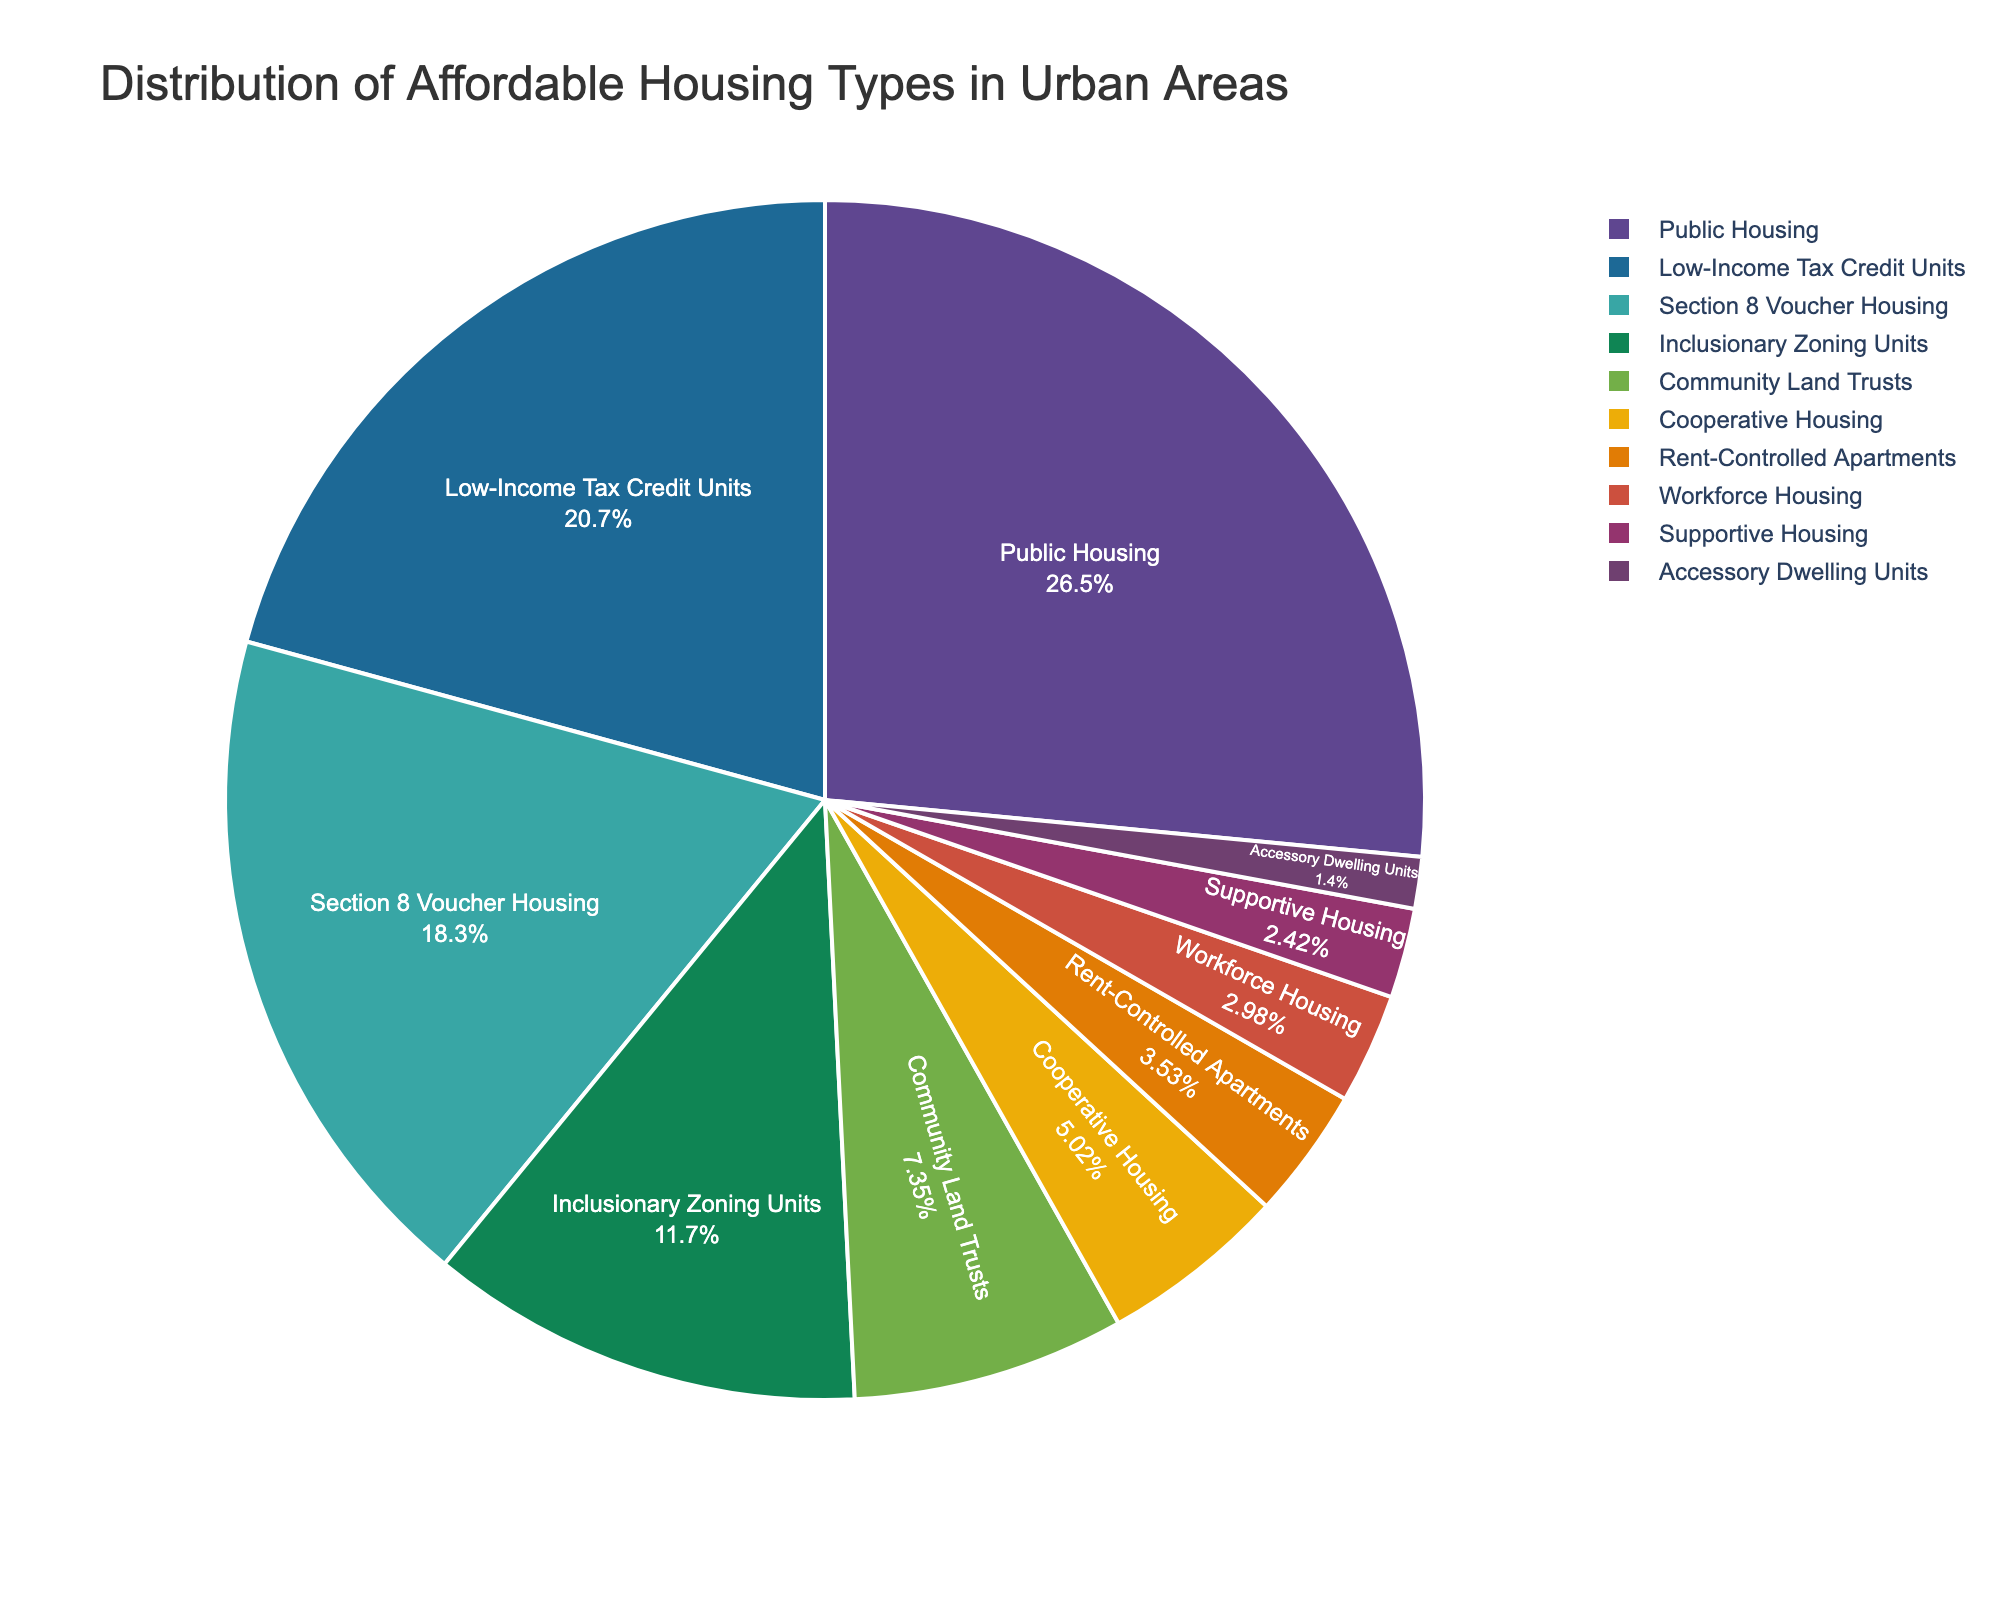What is the largest category in the pie chart? The "Public Housing" category has the largest slice in the pie chart, representing 28.5% of the total distribution.
Answer: Public Housing What is the difference in percentage between the categories "Section 8 Voucher Housing" and "Inclusionary Zoning Units"? "Section 8 Voucher Housing" represents 19.7% and "Inclusionary Zoning Units" represents 12.6%. Subtracting these percentages: 19.7% - 12.6% = 7.1%.
Answer: 7.1% Which affordable housing type constitutes the smallest percentage of the total distribution? The smallest slice in the pie chart represents "Accessory Dwelling Units," which constitutes 1.5% of the total distribution.
Answer: Accessory Dwelling Units Are there more "Community Land Trusts" or "Cooperative Housing"? "Community Land Trusts" represent 7.9%, while "Cooperative Housing" represents 5.4%. Since 7.9% is greater than 5.4%, there are more "Community Land Trusts".
Answer: Community Land Trusts What is the combined percentage of "Rent-Controlled Apartments" and "Workforce Housing"? "Rent-Controlled Apartments" represent 3.8% and "Workforce Housing" represent 3.2%. Their combined percentage is 3.8% + 3.2% = 7.0%.
Answer: 7.0% Which category occupies a greater percentage: "Low-Income Tax Credit Units" or "Section 8 Voucher Housing"? "Low-Income Tax Credit Units" represent 22.3% while "Section 8 Voucher Housing" represents 19.7%. Since 22.3% is greater than 19.7%, "Low-Income Tax Credit Units" occupy a greater percentage.
Answer: Low-Income Tax Credit Units How many affordable housing types have a percentage greater than 10%? The categories greater than 10% are "Public Housing" (28.5%), "Low-Income Tax Credit Units" (22.3%), "Section 8 Voucher Housing" (19.7%), and "Inclusionary Zoning Units" (12.6%). There are 4 such categories.
Answer: 4 Which color represents "Supportive Housing"? "Supportive Housing" is visually represented by a specific color on the pie chart. Looking at the chart, find the slice labeled "Supportive Housing" to determine its color.
Answer: [The exact color as seen on the chart] What is the sum of percentages for "Public Housing", "Low-Income Tax Credit Units", and "Section 8 Voucher Housing"? "Public Housing" represents 28.5%, "Low-Income Tax Credit Units" represent 22.3%, and "Section 8 Voucher Housing" represent 19.7%. Their sum is 28.5% + 22.3% + 19.7% = 70.5%.
Answer: 70.5% 